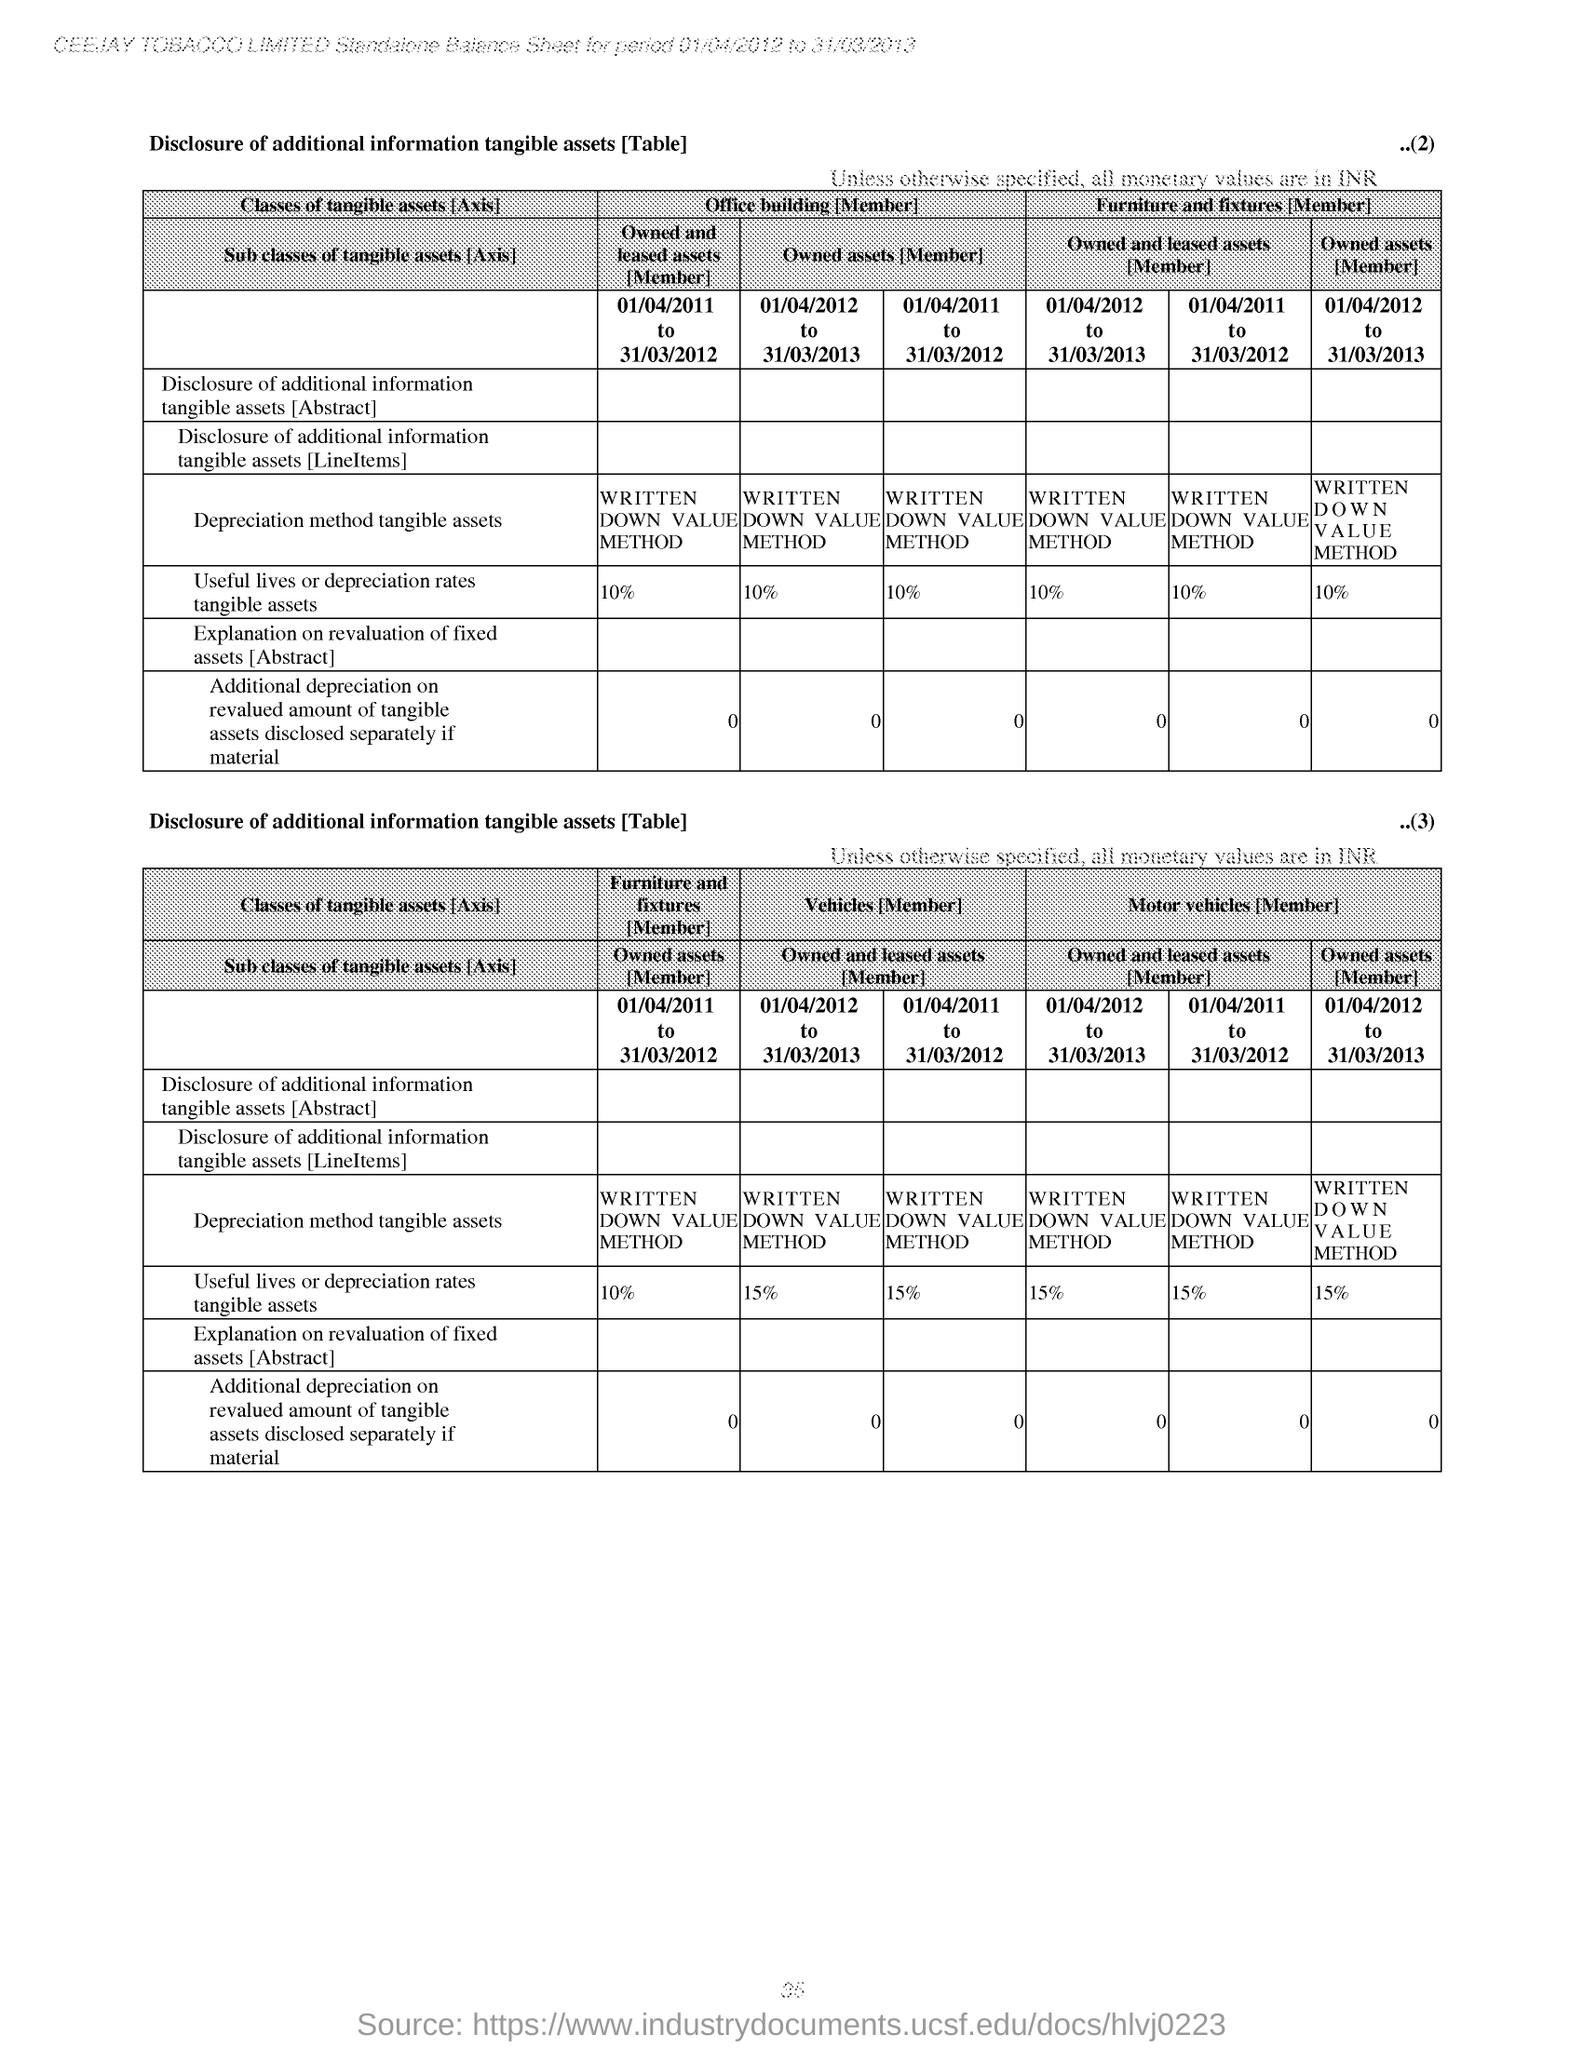Specify some key components in this picture. The useful lives or depreciation rates for the tangible assets listed in the second table for Furniture and fixtures have been provided as 10%. The written down value method is a depreciation method used for tangible assets. The number provided in the top right corner of the first table is 2. Please refer to the number located in the top right corner of the second table (3).. The name of the company mentioned at the top of the page is Ceejay Tobacco Limited. 